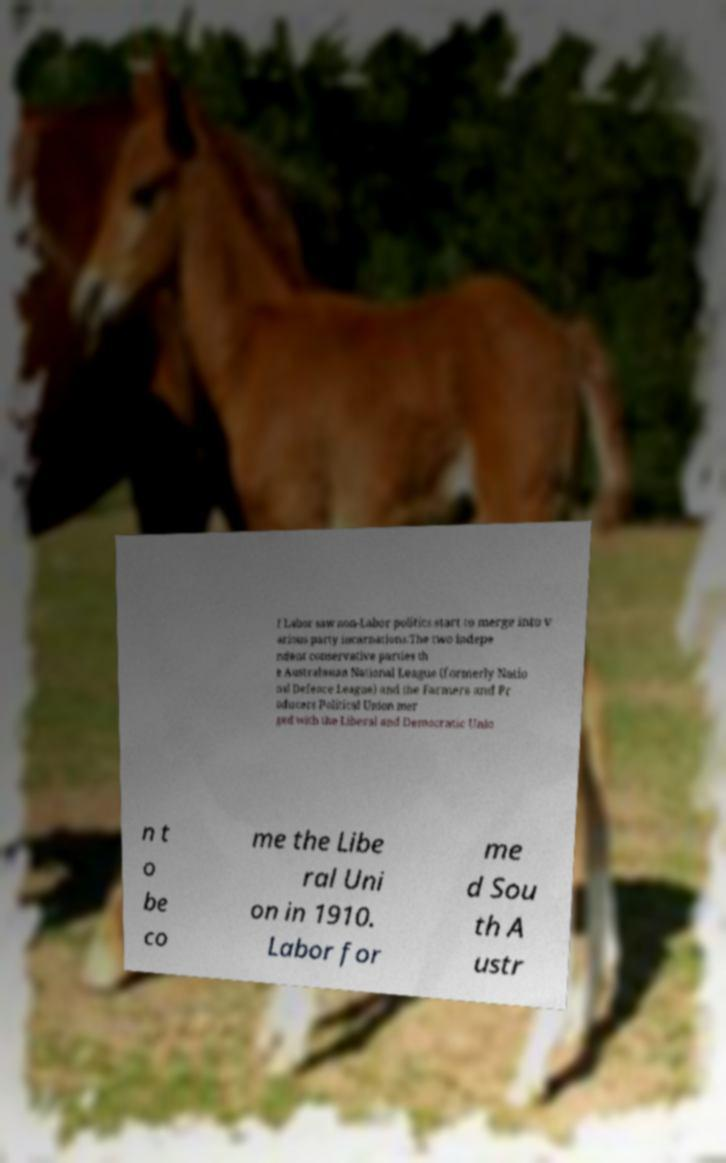For documentation purposes, I need the text within this image transcribed. Could you provide that? f Labor saw non-Labor politics start to merge into v arious party incarnations.The two indepe ndent conservative parties th e Australasian National League (formerly Natio nal Defence League) and the Farmers and Pr oducers Political Union mer ged with the Liberal and Democratic Unio n t o be co me the Libe ral Uni on in 1910. Labor for me d Sou th A ustr 